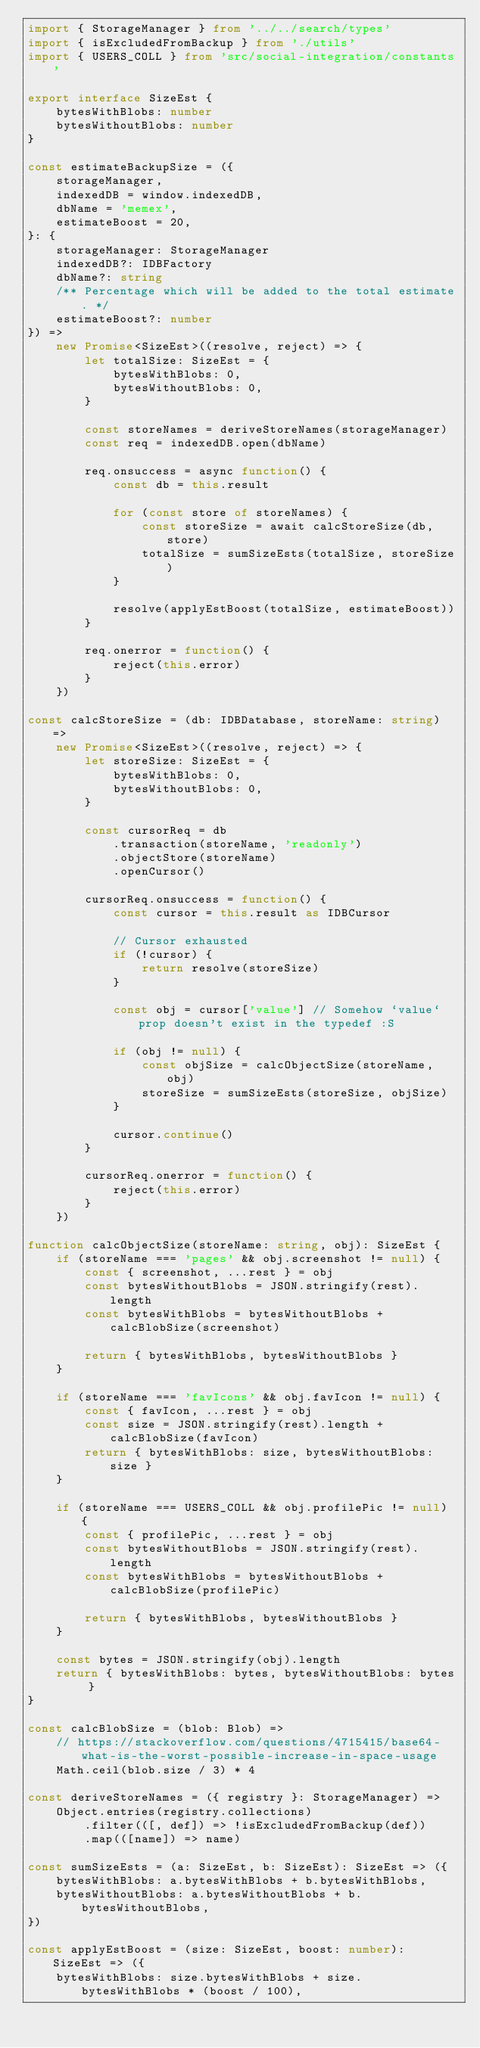Convert code to text. <code><loc_0><loc_0><loc_500><loc_500><_TypeScript_>import { StorageManager } from '../../search/types'
import { isExcludedFromBackup } from './utils'
import { USERS_COLL } from 'src/social-integration/constants'

export interface SizeEst {
    bytesWithBlobs: number
    bytesWithoutBlobs: number
}

const estimateBackupSize = ({
    storageManager,
    indexedDB = window.indexedDB,
    dbName = 'memex',
    estimateBoost = 20,
}: {
    storageManager: StorageManager
    indexedDB?: IDBFactory
    dbName?: string
    /** Percentage which will be added to the total estimate. */
    estimateBoost?: number
}) =>
    new Promise<SizeEst>((resolve, reject) => {
        let totalSize: SizeEst = {
            bytesWithBlobs: 0,
            bytesWithoutBlobs: 0,
        }

        const storeNames = deriveStoreNames(storageManager)
        const req = indexedDB.open(dbName)

        req.onsuccess = async function() {
            const db = this.result

            for (const store of storeNames) {
                const storeSize = await calcStoreSize(db, store)
                totalSize = sumSizeEsts(totalSize, storeSize)
            }

            resolve(applyEstBoost(totalSize, estimateBoost))
        }

        req.onerror = function() {
            reject(this.error)
        }
    })

const calcStoreSize = (db: IDBDatabase, storeName: string) =>
    new Promise<SizeEst>((resolve, reject) => {
        let storeSize: SizeEst = {
            bytesWithBlobs: 0,
            bytesWithoutBlobs: 0,
        }

        const cursorReq = db
            .transaction(storeName, 'readonly')
            .objectStore(storeName)
            .openCursor()

        cursorReq.onsuccess = function() {
            const cursor = this.result as IDBCursor

            // Cursor exhausted
            if (!cursor) {
                return resolve(storeSize)
            }

            const obj = cursor['value'] // Somehow `value` prop doesn't exist in the typedef :S

            if (obj != null) {
                const objSize = calcObjectSize(storeName, obj)
                storeSize = sumSizeEsts(storeSize, objSize)
            }

            cursor.continue()
        }

        cursorReq.onerror = function() {
            reject(this.error)
        }
    })

function calcObjectSize(storeName: string, obj): SizeEst {
    if (storeName === 'pages' && obj.screenshot != null) {
        const { screenshot, ...rest } = obj
        const bytesWithoutBlobs = JSON.stringify(rest).length
        const bytesWithBlobs = bytesWithoutBlobs + calcBlobSize(screenshot)

        return { bytesWithBlobs, bytesWithoutBlobs }
    }

    if (storeName === 'favIcons' && obj.favIcon != null) {
        const { favIcon, ...rest } = obj
        const size = JSON.stringify(rest).length + calcBlobSize(favIcon)
        return { bytesWithBlobs: size, bytesWithoutBlobs: size }
    }

    if (storeName === USERS_COLL && obj.profilePic != null) {
        const { profilePic, ...rest } = obj
        const bytesWithoutBlobs = JSON.stringify(rest).length
        const bytesWithBlobs = bytesWithoutBlobs + calcBlobSize(profilePic)

        return { bytesWithBlobs, bytesWithoutBlobs }
    }

    const bytes = JSON.stringify(obj).length
    return { bytesWithBlobs: bytes, bytesWithoutBlobs: bytes }
}

const calcBlobSize = (blob: Blob) =>
    // https://stackoverflow.com/questions/4715415/base64-what-is-the-worst-possible-increase-in-space-usage
    Math.ceil(blob.size / 3) * 4

const deriveStoreNames = ({ registry }: StorageManager) =>
    Object.entries(registry.collections)
        .filter(([, def]) => !isExcludedFromBackup(def))
        .map(([name]) => name)

const sumSizeEsts = (a: SizeEst, b: SizeEst): SizeEst => ({
    bytesWithBlobs: a.bytesWithBlobs + b.bytesWithBlobs,
    bytesWithoutBlobs: a.bytesWithoutBlobs + b.bytesWithoutBlobs,
})

const applyEstBoost = (size: SizeEst, boost: number): SizeEst => ({
    bytesWithBlobs: size.bytesWithBlobs + size.bytesWithBlobs * (boost / 100),</code> 